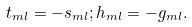Convert formula to latex. <formula><loc_0><loc_0><loc_500><loc_500>t _ { m l } = - s _ { m l } ; h _ { m l } = - g _ { m l } .</formula> 